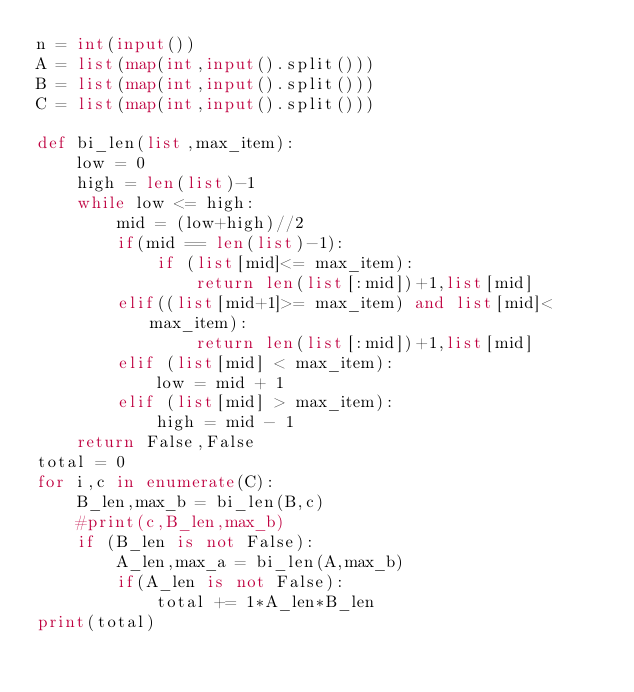<code> <loc_0><loc_0><loc_500><loc_500><_Python_>n = int(input())
A = list(map(int,input().split()))
B = list(map(int,input().split()))
C = list(map(int,input().split()))

def bi_len(list,max_item):
    low = 0
    high = len(list)-1
    while low <= high:
        mid = (low+high)//2
        if(mid == len(list)-1):
            if (list[mid]<= max_item):
                return len(list[:mid])+1,list[mid]
        elif((list[mid+1]>= max_item) and list[mid]< max_item):
                return len(list[:mid])+1,list[mid]
        elif (list[mid] < max_item):
            low = mid + 1
        elif (list[mid] > max_item):
            high = mid - 1
    return False,False
total = 0
for i,c in enumerate(C):
    B_len,max_b = bi_len(B,c)
    #print(c,B_len,max_b)
    if (B_len is not False):
        A_len,max_a = bi_len(A,max_b)
        if(A_len is not False):
            total += 1*A_len*B_len
print(total)
</code> 